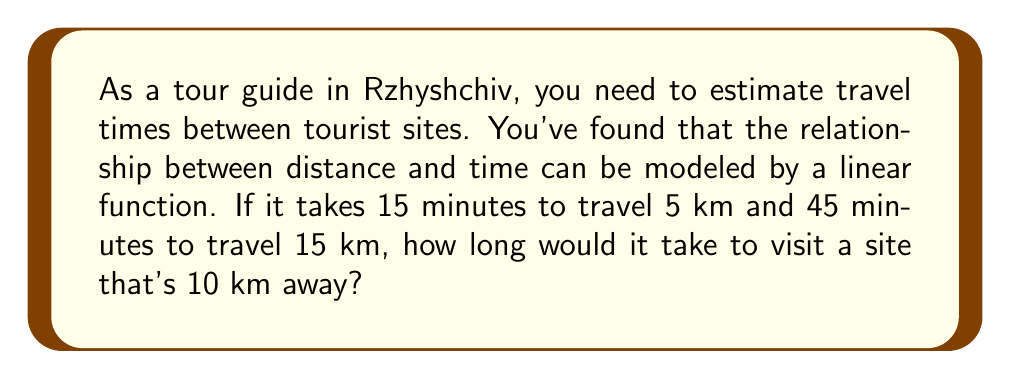Solve this math problem. Let's approach this step-by-step:

1) We can represent the linear function as $y = mx + b$, where:
   $y$ is the time in minutes
   $x$ is the distance in kilometers
   $m$ is the slope (rate of change)
   $b$ is the y-intercept

2) We have two points: (5, 15) and (15, 45). Let's find the slope:

   $m = \frac{y_2 - y_1}{x_2 - x_1} = \frac{45 - 15}{15 - 5} = \frac{30}{10} = 3$

3) This means it takes 3 minutes to travel each kilometer.

4) Now let's find the y-intercept using either point. Let's use (5, 15):

   $15 = 3(5) + b$
   $15 = 15 + b$
   $b = 0$

5) So our linear function is:

   $y = 3x + 0$ or simply $y = 3x$

6) To find the time for 10 km, we substitute $x = 10$:

   $y = 3(10) = 30$

Therefore, it would take 30 minutes to travel 10 km.
Answer: 30 minutes 